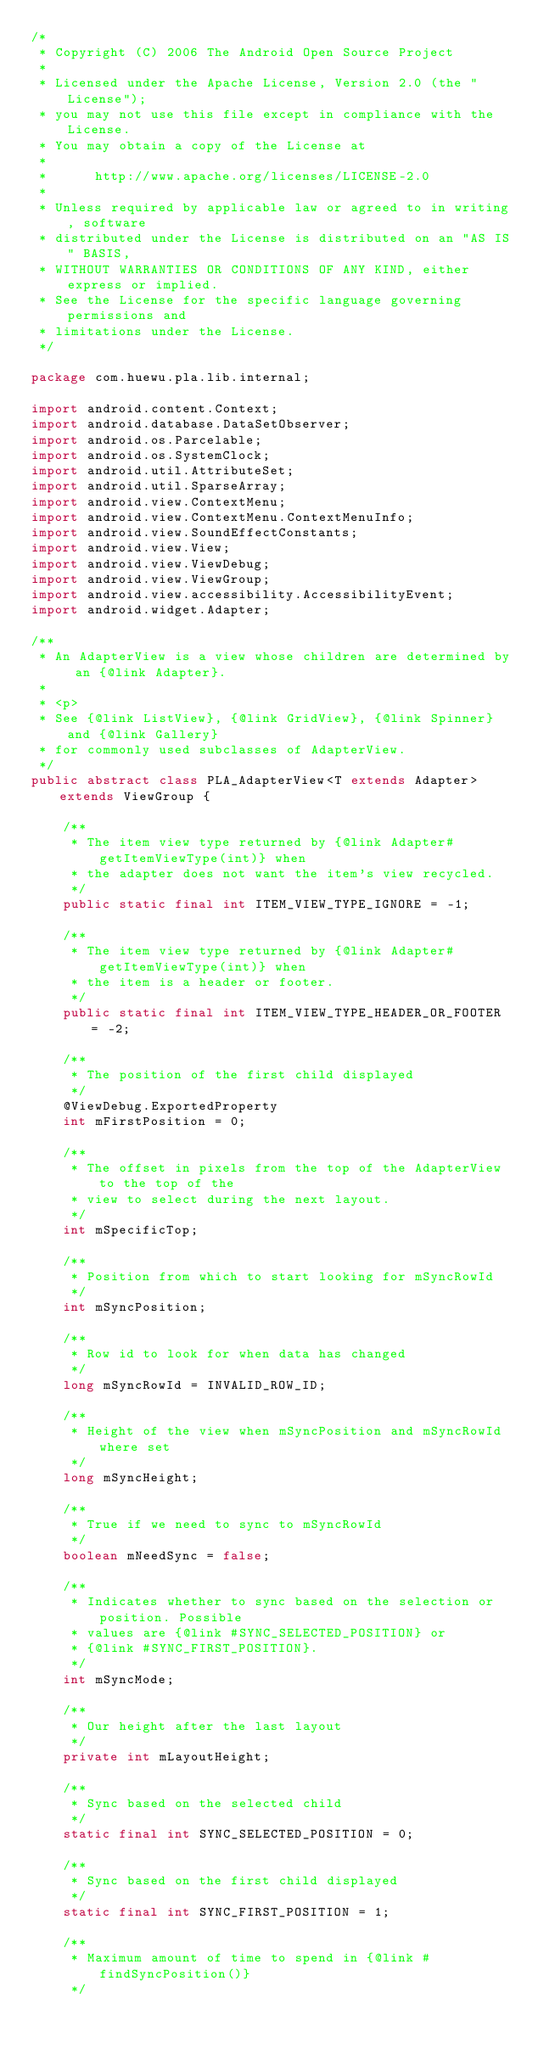Convert code to text. <code><loc_0><loc_0><loc_500><loc_500><_Java_>/*
 * Copyright (C) 2006 The Android Open Source Project
 *
 * Licensed under the Apache License, Version 2.0 (the "License");
 * you may not use this file except in compliance with the License.
 * You may obtain a copy of the License at
 *
 *      http://www.apache.org/licenses/LICENSE-2.0
 *
 * Unless required by applicable law or agreed to in writing, software
 * distributed under the License is distributed on an "AS IS" BASIS,
 * WITHOUT WARRANTIES OR CONDITIONS OF ANY KIND, either express or implied.
 * See the License for the specific language governing permissions and
 * limitations under the License.
 */

package com.huewu.pla.lib.internal;

import android.content.Context;
import android.database.DataSetObserver;
import android.os.Parcelable;
import android.os.SystemClock;
import android.util.AttributeSet;
import android.util.SparseArray;
import android.view.ContextMenu;
import android.view.ContextMenu.ContextMenuInfo;
import android.view.SoundEffectConstants;
import android.view.View;
import android.view.ViewDebug;
import android.view.ViewGroup;
import android.view.accessibility.AccessibilityEvent;
import android.widget.Adapter;

/**
 * An AdapterView is a view whose children are determined by an {@link Adapter}.
 * 
 * <p>
 * See {@link ListView}, {@link GridView}, {@link Spinner} and {@link Gallery}
 * for commonly used subclasses of AdapterView.
 */
public abstract class PLA_AdapterView<T extends Adapter> extends ViewGroup {

    /**
     * The item view type returned by {@link Adapter#getItemViewType(int)} when
     * the adapter does not want the item's view recycled.
     */
    public static final int ITEM_VIEW_TYPE_IGNORE = -1;

    /**
     * The item view type returned by {@link Adapter#getItemViewType(int)} when
     * the item is a header or footer.
     */
    public static final int ITEM_VIEW_TYPE_HEADER_OR_FOOTER = -2;

    /**
     * The position of the first child displayed
     */
    @ViewDebug.ExportedProperty
    int mFirstPosition = 0;

    /**
     * The offset in pixels from the top of the AdapterView to the top of the
     * view to select during the next layout.
     */
    int mSpecificTop;

    /**
     * Position from which to start looking for mSyncRowId
     */
    int mSyncPosition;

    /**
     * Row id to look for when data has changed
     */
    long mSyncRowId = INVALID_ROW_ID;

    /**
     * Height of the view when mSyncPosition and mSyncRowId where set
     */
    long mSyncHeight;

    /**
     * True if we need to sync to mSyncRowId
     */
    boolean mNeedSync = false;

    /**
     * Indicates whether to sync based on the selection or position. Possible
     * values are {@link #SYNC_SELECTED_POSITION} or
     * {@link #SYNC_FIRST_POSITION}.
     */
    int mSyncMode;

    /**
     * Our height after the last layout
     */
    private int mLayoutHeight;

    /**
     * Sync based on the selected child
     */
    static final int SYNC_SELECTED_POSITION = 0;

    /**
     * Sync based on the first child displayed
     */
    static final int SYNC_FIRST_POSITION = 1;

    /**
     * Maximum amount of time to spend in {@link #findSyncPosition()}
     */</code> 